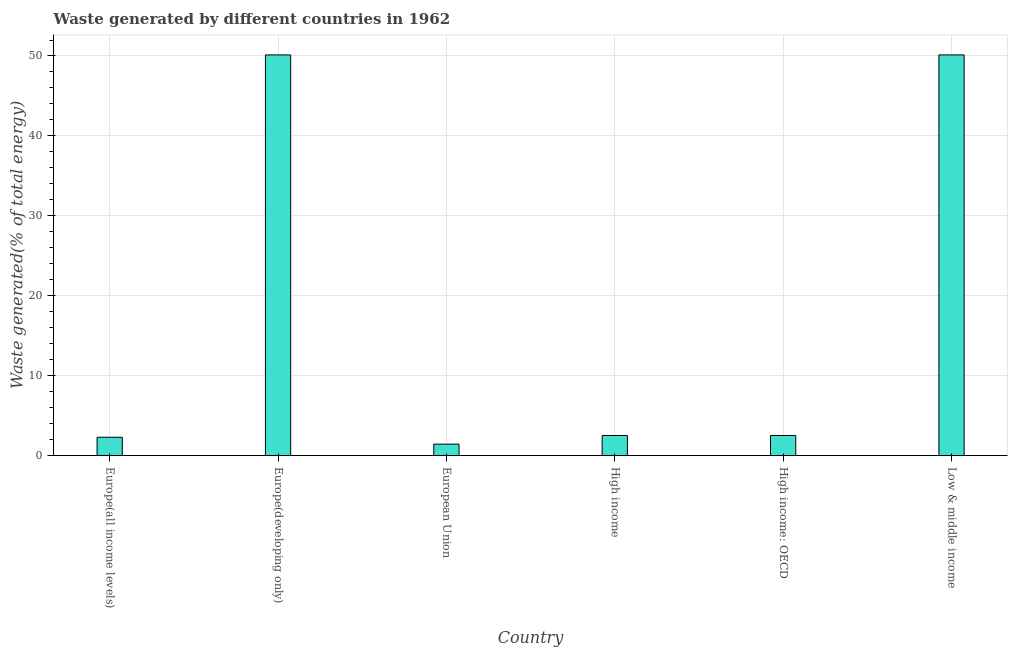Does the graph contain grids?
Keep it short and to the point. Yes. What is the title of the graph?
Make the answer very short. Waste generated by different countries in 1962. What is the label or title of the Y-axis?
Provide a short and direct response. Waste generated(% of total energy). What is the amount of waste generated in Europe(all income levels)?
Provide a succinct answer. 2.31. Across all countries, what is the maximum amount of waste generated?
Give a very brief answer. 50.13. Across all countries, what is the minimum amount of waste generated?
Offer a very short reply. 1.45. In which country was the amount of waste generated maximum?
Make the answer very short. Europe(developing only). What is the sum of the amount of waste generated?
Offer a very short reply. 109.09. What is the difference between the amount of waste generated in Europe(developing only) and High income: OECD?
Your answer should be compact. 47.6. What is the average amount of waste generated per country?
Keep it short and to the point. 18.18. What is the median amount of waste generated?
Provide a short and direct response. 2.53. What is the ratio of the amount of waste generated in Europe(all income levels) to that in High income: OECD?
Provide a succinct answer. 0.91. Is the amount of waste generated in Europe(all income levels) less than that in High income: OECD?
Your response must be concise. Yes. What is the difference between the highest and the second highest amount of waste generated?
Ensure brevity in your answer.  0. What is the difference between the highest and the lowest amount of waste generated?
Offer a terse response. 48.69. In how many countries, is the amount of waste generated greater than the average amount of waste generated taken over all countries?
Make the answer very short. 2. How many countries are there in the graph?
Your response must be concise. 6. What is the difference between two consecutive major ticks on the Y-axis?
Give a very brief answer. 10. Are the values on the major ticks of Y-axis written in scientific E-notation?
Provide a short and direct response. No. What is the Waste generated(% of total energy) in Europe(all income levels)?
Provide a short and direct response. 2.31. What is the Waste generated(% of total energy) of Europe(developing only)?
Provide a short and direct response. 50.13. What is the Waste generated(% of total energy) of European Union?
Ensure brevity in your answer.  1.45. What is the Waste generated(% of total energy) of High income?
Your response must be concise. 2.53. What is the Waste generated(% of total energy) in High income: OECD?
Provide a short and direct response. 2.53. What is the Waste generated(% of total energy) in Low & middle income?
Your response must be concise. 50.13. What is the difference between the Waste generated(% of total energy) in Europe(all income levels) and Europe(developing only)?
Provide a succinct answer. -47.83. What is the difference between the Waste generated(% of total energy) in Europe(all income levels) and European Union?
Give a very brief answer. 0.86. What is the difference between the Waste generated(% of total energy) in Europe(all income levels) and High income?
Your answer should be compact. -0.22. What is the difference between the Waste generated(% of total energy) in Europe(all income levels) and High income: OECD?
Your answer should be very brief. -0.22. What is the difference between the Waste generated(% of total energy) in Europe(all income levels) and Low & middle income?
Keep it short and to the point. -47.83. What is the difference between the Waste generated(% of total energy) in Europe(developing only) and European Union?
Offer a terse response. 48.69. What is the difference between the Waste generated(% of total energy) in Europe(developing only) and High income?
Make the answer very short. 47.6. What is the difference between the Waste generated(% of total energy) in Europe(developing only) and High income: OECD?
Offer a very short reply. 47.6. What is the difference between the Waste generated(% of total energy) in European Union and High income?
Make the answer very short. -1.08. What is the difference between the Waste generated(% of total energy) in European Union and High income: OECD?
Your response must be concise. -1.08. What is the difference between the Waste generated(% of total energy) in European Union and Low & middle income?
Offer a very short reply. -48.69. What is the difference between the Waste generated(% of total energy) in High income and High income: OECD?
Offer a terse response. 0. What is the difference between the Waste generated(% of total energy) in High income and Low & middle income?
Provide a short and direct response. -47.6. What is the difference between the Waste generated(% of total energy) in High income: OECD and Low & middle income?
Offer a very short reply. -47.6. What is the ratio of the Waste generated(% of total energy) in Europe(all income levels) to that in Europe(developing only)?
Give a very brief answer. 0.05. What is the ratio of the Waste generated(% of total energy) in Europe(all income levels) to that in European Union?
Ensure brevity in your answer.  1.59. What is the ratio of the Waste generated(% of total energy) in Europe(all income levels) to that in High income?
Give a very brief answer. 0.91. What is the ratio of the Waste generated(% of total energy) in Europe(all income levels) to that in High income: OECD?
Offer a very short reply. 0.91. What is the ratio of the Waste generated(% of total energy) in Europe(all income levels) to that in Low & middle income?
Provide a short and direct response. 0.05. What is the ratio of the Waste generated(% of total energy) in Europe(developing only) to that in European Union?
Give a very brief answer. 34.59. What is the ratio of the Waste generated(% of total energy) in Europe(developing only) to that in High income?
Give a very brief answer. 19.81. What is the ratio of the Waste generated(% of total energy) in Europe(developing only) to that in High income: OECD?
Offer a very short reply. 19.81. What is the ratio of the Waste generated(% of total energy) in European Union to that in High income?
Offer a terse response. 0.57. What is the ratio of the Waste generated(% of total energy) in European Union to that in High income: OECD?
Keep it short and to the point. 0.57. What is the ratio of the Waste generated(% of total energy) in European Union to that in Low & middle income?
Make the answer very short. 0.03. What is the ratio of the Waste generated(% of total energy) in High income to that in High income: OECD?
Keep it short and to the point. 1. What is the ratio of the Waste generated(% of total energy) in High income to that in Low & middle income?
Give a very brief answer. 0.05. 